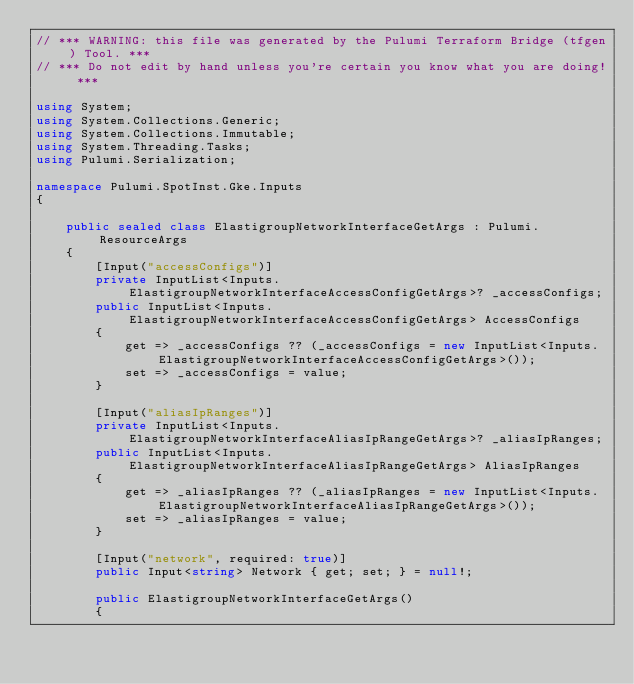Convert code to text. <code><loc_0><loc_0><loc_500><loc_500><_C#_>// *** WARNING: this file was generated by the Pulumi Terraform Bridge (tfgen) Tool. ***
// *** Do not edit by hand unless you're certain you know what you are doing! ***

using System;
using System.Collections.Generic;
using System.Collections.Immutable;
using System.Threading.Tasks;
using Pulumi.Serialization;

namespace Pulumi.SpotInst.Gke.Inputs
{

    public sealed class ElastigroupNetworkInterfaceGetArgs : Pulumi.ResourceArgs
    {
        [Input("accessConfigs")]
        private InputList<Inputs.ElastigroupNetworkInterfaceAccessConfigGetArgs>? _accessConfigs;
        public InputList<Inputs.ElastigroupNetworkInterfaceAccessConfigGetArgs> AccessConfigs
        {
            get => _accessConfigs ?? (_accessConfigs = new InputList<Inputs.ElastigroupNetworkInterfaceAccessConfigGetArgs>());
            set => _accessConfigs = value;
        }

        [Input("aliasIpRanges")]
        private InputList<Inputs.ElastigroupNetworkInterfaceAliasIpRangeGetArgs>? _aliasIpRanges;
        public InputList<Inputs.ElastigroupNetworkInterfaceAliasIpRangeGetArgs> AliasIpRanges
        {
            get => _aliasIpRanges ?? (_aliasIpRanges = new InputList<Inputs.ElastigroupNetworkInterfaceAliasIpRangeGetArgs>());
            set => _aliasIpRanges = value;
        }

        [Input("network", required: true)]
        public Input<string> Network { get; set; } = null!;

        public ElastigroupNetworkInterfaceGetArgs()
        {</code> 